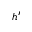<formula> <loc_0><loc_0><loc_500><loc_500>h ^ { \prime }</formula> 